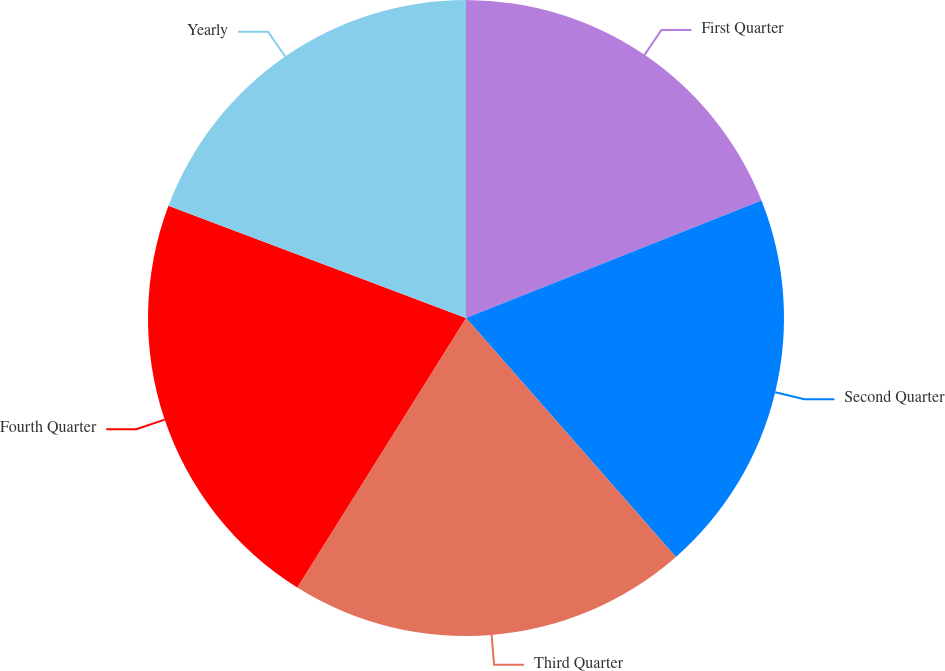Convert chart to OTSL. <chart><loc_0><loc_0><loc_500><loc_500><pie_chart><fcel>First Quarter<fcel>Second Quarter<fcel>Third Quarter<fcel>Fourth Quarter<fcel>Yearly<nl><fcel>18.98%<fcel>19.55%<fcel>20.38%<fcel>21.84%<fcel>19.26%<nl></chart> 